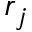Convert formula to latex. <formula><loc_0><loc_0><loc_500><loc_500>r _ { j }</formula> 